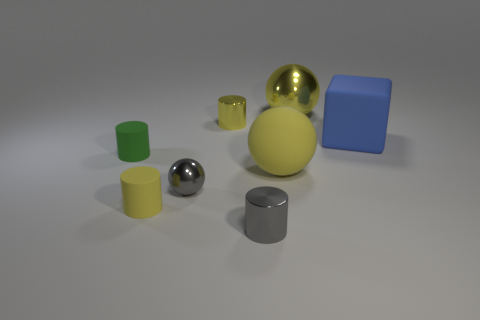What number of yellow objects are small metallic spheres or large spheres?
Ensure brevity in your answer.  2. Is there a object that has the same size as the yellow rubber sphere?
Provide a short and direct response. Yes. What is the material of the cube that is the same size as the yellow matte ball?
Offer a terse response. Rubber. Does the shiny cylinder behind the large rubber block have the same size as the gray metal ball in front of the tiny green cylinder?
Ensure brevity in your answer.  Yes. What number of things are tiny yellow metallic cylinders or yellow balls that are in front of the green rubber cylinder?
Provide a short and direct response. 2. Are there any small yellow objects that have the same shape as the big metallic thing?
Offer a terse response. No. There is a sphere that is behind the large yellow ball that is left of the big yellow metallic ball; what size is it?
Make the answer very short. Large. Is the color of the large rubber ball the same as the rubber cube?
Offer a terse response. No. What number of metallic objects are gray cylinders or gray spheres?
Your answer should be compact. 2. What number of small shiny things are there?
Offer a terse response. 3. 